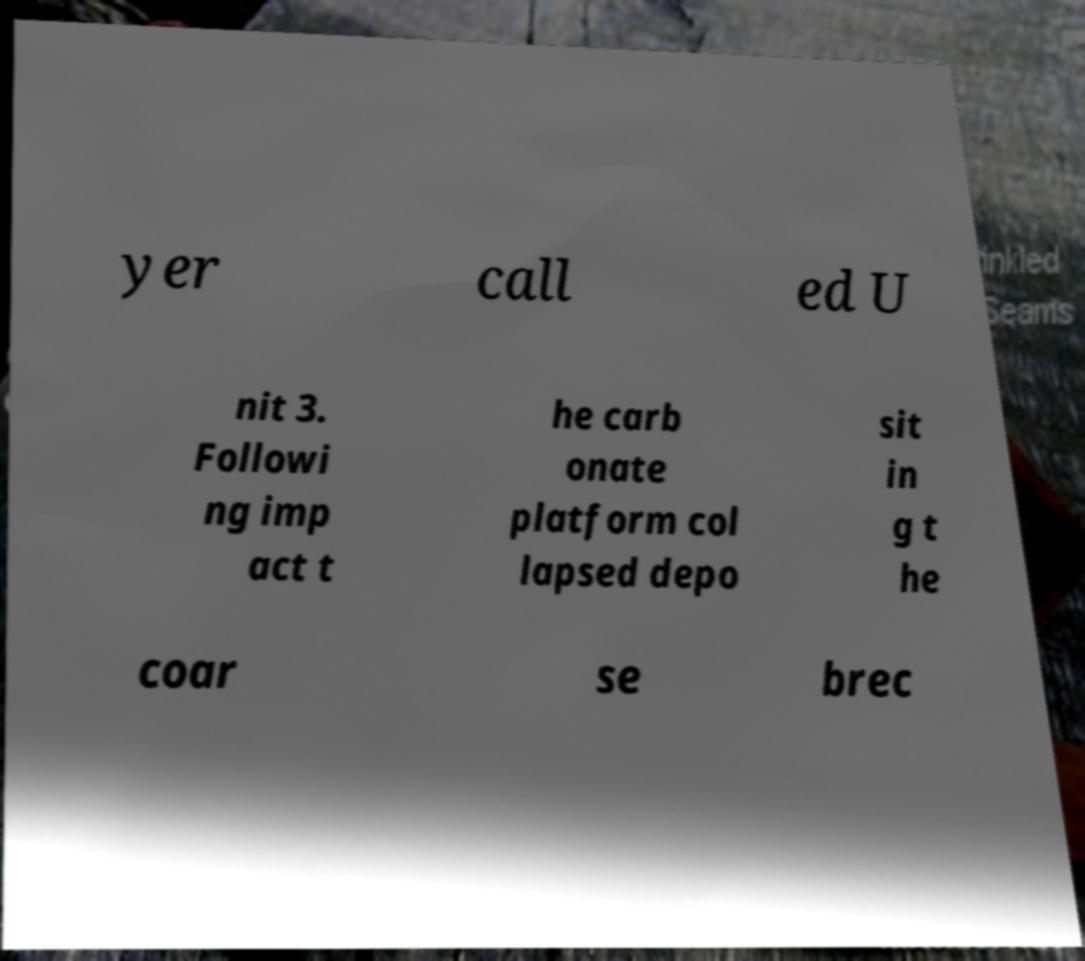Could you extract and type out the text from this image? yer call ed U nit 3. Followi ng imp act t he carb onate platform col lapsed depo sit in g t he coar se brec 